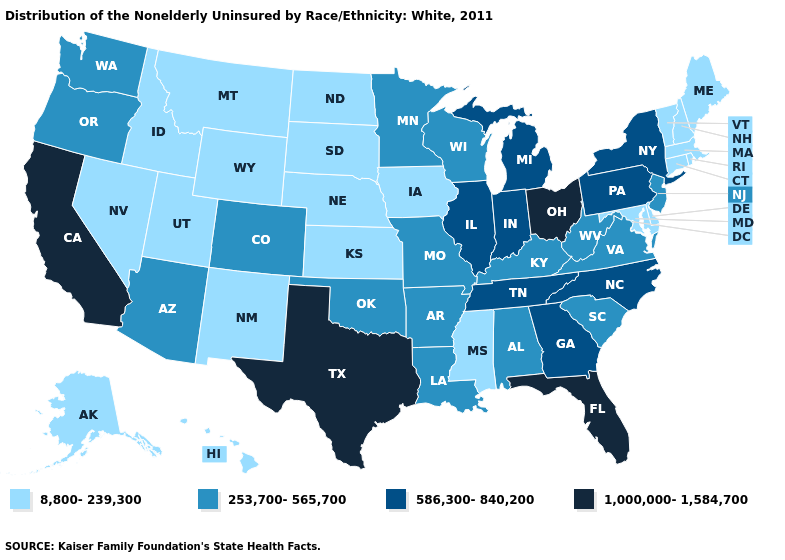What is the value of Colorado?
Short answer required. 253,700-565,700. Which states hav the highest value in the Northeast?
Give a very brief answer. New York, Pennsylvania. What is the value of Mississippi?
Concise answer only. 8,800-239,300. What is the value of Kentucky?
Quick response, please. 253,700-565,700. What is the value of Hawaii?
Give a very brief answer. 8,800-239,300. Which states have the highest value in the USA?
Short answer required. California, Florida, Ohio, Texas. What is the lowest value in the MidWest?
Quick response, please. 8,800-239,300. Name the states that have a value in the range 1,000,000-1,584,700?
Short answer required. California, Florida, Ohio, Texas. Does Alabama have the highest value in the USA?
Be succinct. No. What is the value of Utah?
Be succinct. 8,800-239,300. Name the states that have a value in the range 1,000,000-1,584,700?
Keep it brief. California, Florida, Ohio, Texas. Name the states that have a value in the range 8,800-239,300?
Be succinct. Alaska, Connecticut, Delaware, Hawaii, Idaho, Iowa, Kansas, Maine, Maryland, Massachusetts, Mississippi, Montana, Nebraska, Nevada, New Hampshire, New Mexico, North Dakota, Rhode Island, South Dakota, Utah, Vermont, Wyoming. What is the lowest value in states that border Oklahoma?
Quick response, please. 8,800-239,300. Name the states that have a value in the range 8,800-239,300?
Give a very brief answer. Alaska, Connecticut, Delaware, Hawaii, Idaho, Iowa, Kansas, Maine, Maryland, Massachusetts, Mississippi, Montana, Nebraska, Nevada, New Hampshire, New Mexico, North Dakota, Rhode Island, South Dakota, Utah, Vermont, Wyoming. Which states have the lowest value in the USA?
Write a very short answer. Alaska, Connecticut, Delaware, Hawaii, Idaho, Iowa, Kansas, Maine, Maryland, Massachusetts, Mississippi, Montana, Nebraska, Nevada, New Hampshire, New Mexico, North Dakota, Rhode Island, South Dakota, Utah, Vermont, Wyoming. 